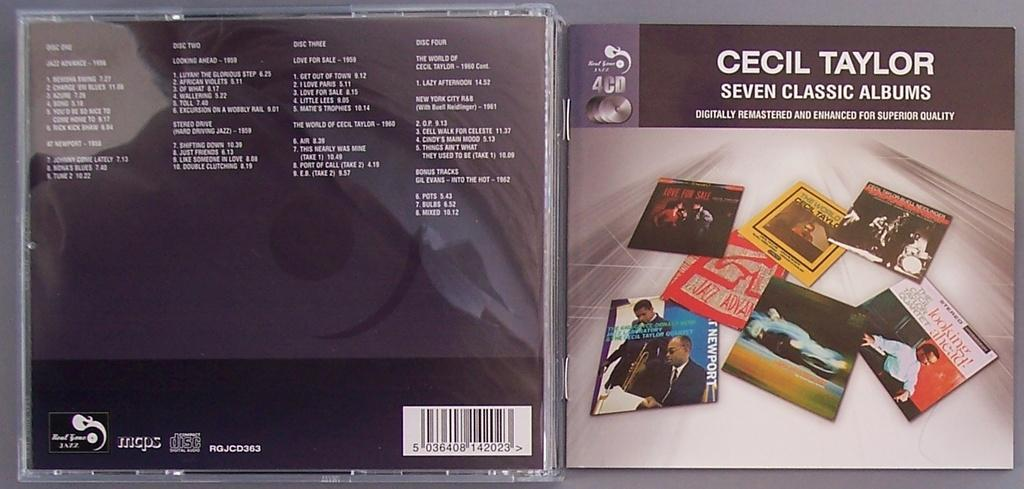<image>
Describe the image concisely. a CD cover by the artist Cecil Taylor 